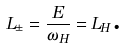Convert formula to latex. <formula><loc_0><loc_0><loc_500><loc_500>L _ { \pm } = \frac { E } { \omega _ { H } } = L _ { H } \text {.}</formula> 